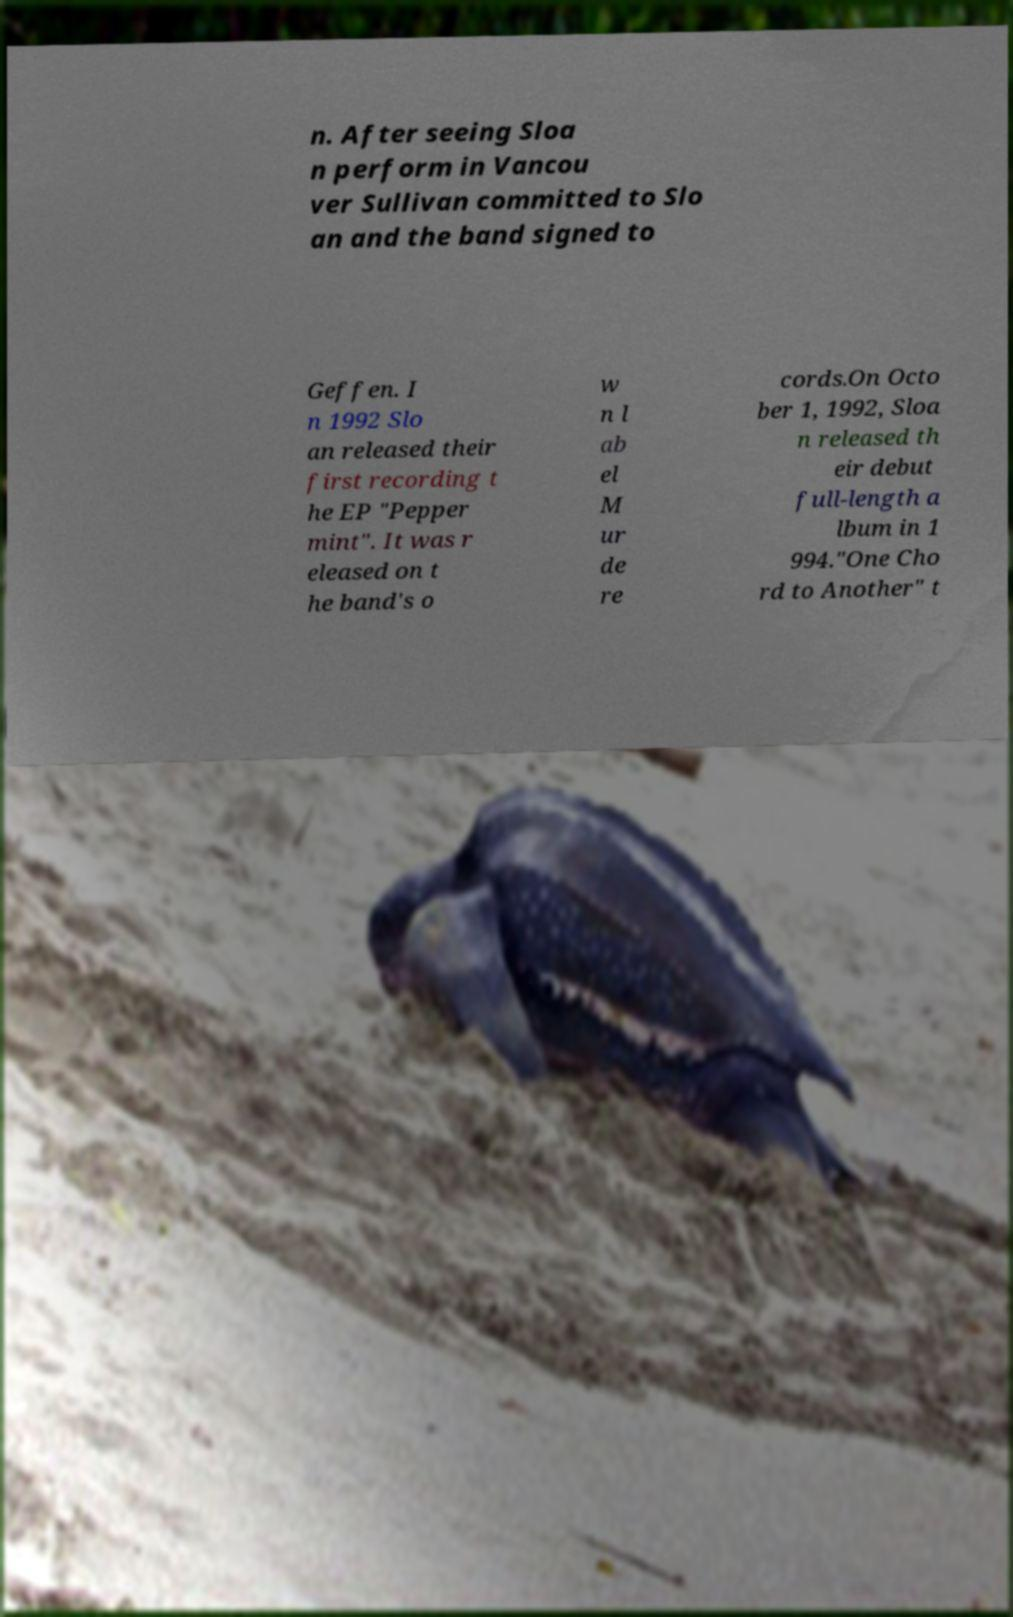For documentation purposes, I need the text within this image transcribed. Could you provide that? n. After seeing Sloa n perform in Vancou ver Sullivan committed to Slo an and the band signed to Geffen. I n 1992 Slo an released their first recording t he EP "Pepper mint". It was r eleased on t he band's o w n l ab el M ur de re cords.On Octo ber 1, 1992, Sloa n released th eir debut full-length a lbum in 1 994."One Cho rd to Another" t 